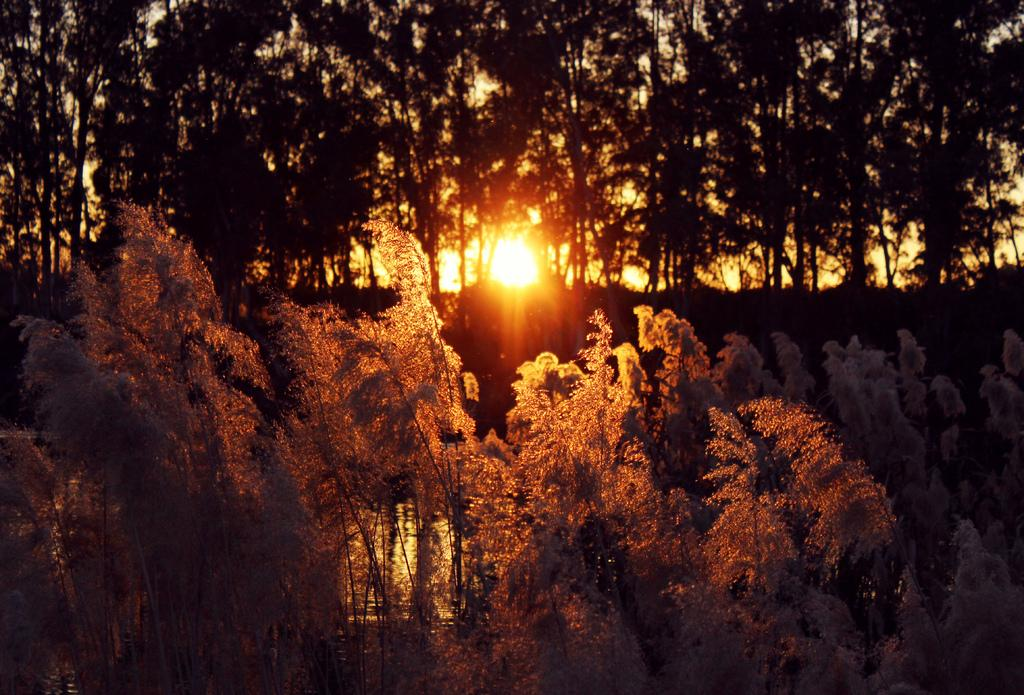What celestial body can be seen in the image? The sun is visible in the image. What type of vegetation is present in the image? There are trees and plants in the image. What type of bone can be seen in the image? There is no bone present in the image. What musical instrument is being played in the image? There is no musical instrument being played in the image. 